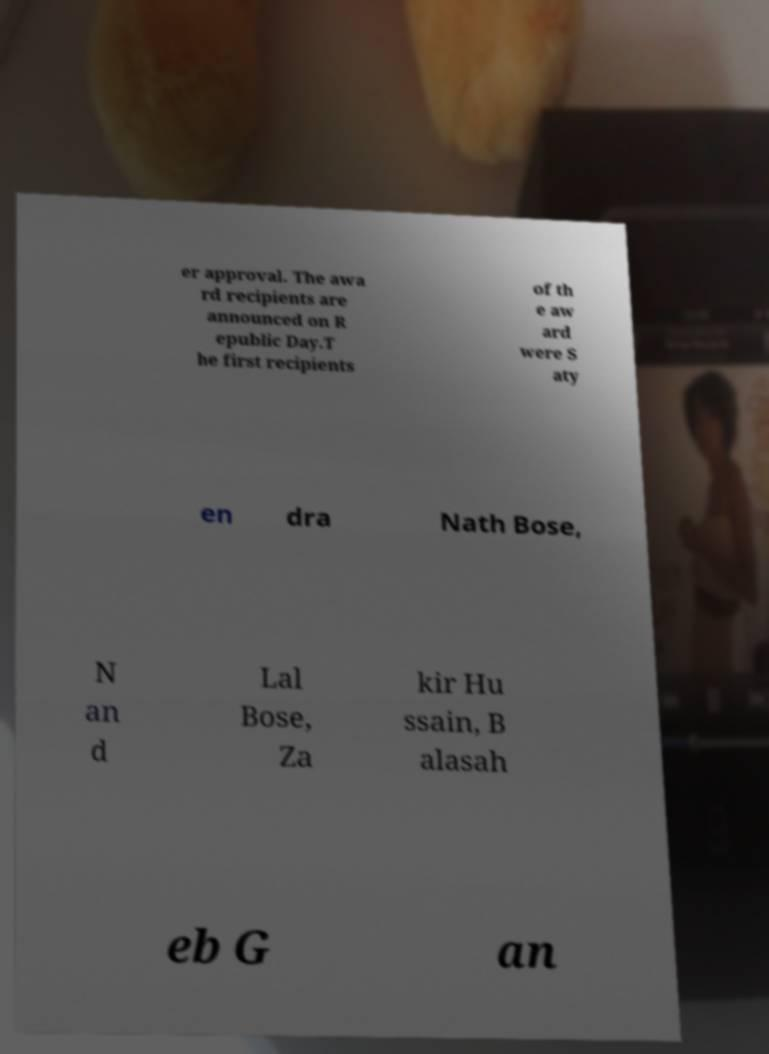I need the written content from this picture converted into text. Can you do that? er approval. The awa rd recipients are announced on R epublic Day.T he first recipients of th e aw ard were S aty en dra Nath Bose, N an d Lal Bose, Za kir Hu ssain, B alasah eb G an 